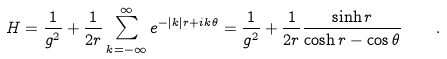<formula> <loc_0><loc_0><loc_500><loc_500>H = \frac { 1 } { g ^ { 2 } } + \frac { 1 } { 2 r } \sum _ { k = - \infty } ^ { \infty } e ^ { - | k | r + i k \theta } = \frac { 1 } { g ^ { 2 } } + \frac { 1 } { 2 r } \frac { \sinh r } { \cosh r - \cos \theta } \quad .</formula> 